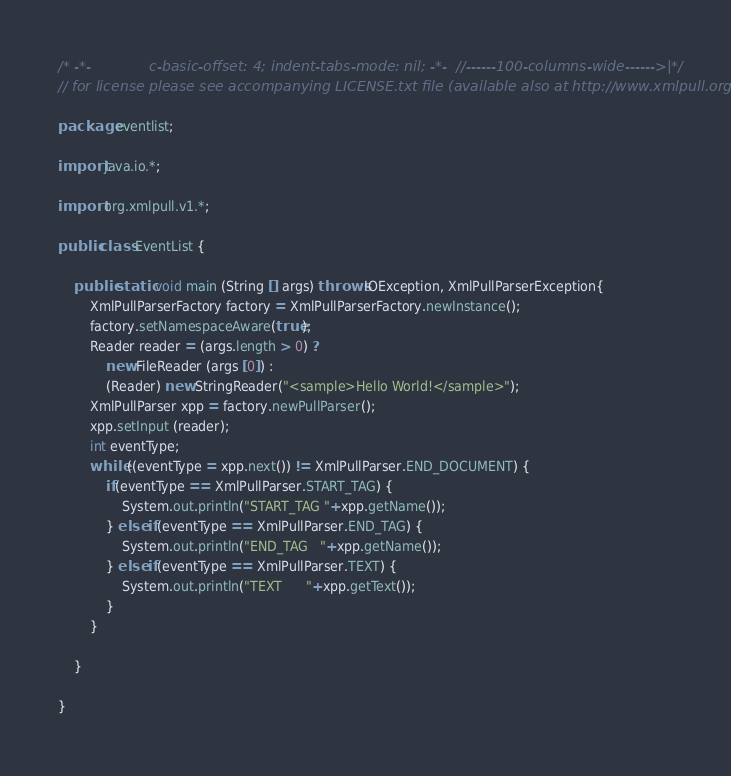Convert code to text. <code><loc_0><loc_0><loc_500><loc_500><_Java_>/* -*-             c-basic-offset: 4; indent-tabs-mode: nil; -*-  //------100-columns-wide------>|*/
// for license please see accompanying LICENSE.txt file (available also at http://www.xmlpull.org/)

package eventlist;

import java.io.*;

import org.xmlpull.v1.*;

public class EventList {

    public static void main (String [] args) throws IOException, XmlPullParserException{
        XmlPullParserFactory factory = XmlPullParserFactory.newInstance();
        factory.setNamespaceAware(true);
        Reader reader = (args.length > 0) ?
            new FileReader (args [0]) :
            (Reader) new StringReader("<sample>Hello World!</sample>");
        XmlPullParser xpp = factory.newPullParser();
        xpp.setInput (reader);
        int eventType;
        while ((eventType = xpp.next()) != XmlPullParser.END_DOCUMENT) {
            if(eventType == XmlPullParser.START_TAG) {
                System.out.println("START_TAG "+xpp.getName());
            } else if(eventType == XmlPullParser.END_TAG) {
                System.out.println("END_TAG   "+xpp.getName());
            } else if(eventType == XmlPullParser.TEXT) {
                System.out.println("TEXT      "+xpp.getText());
            }
        }

    }

}

</code> 